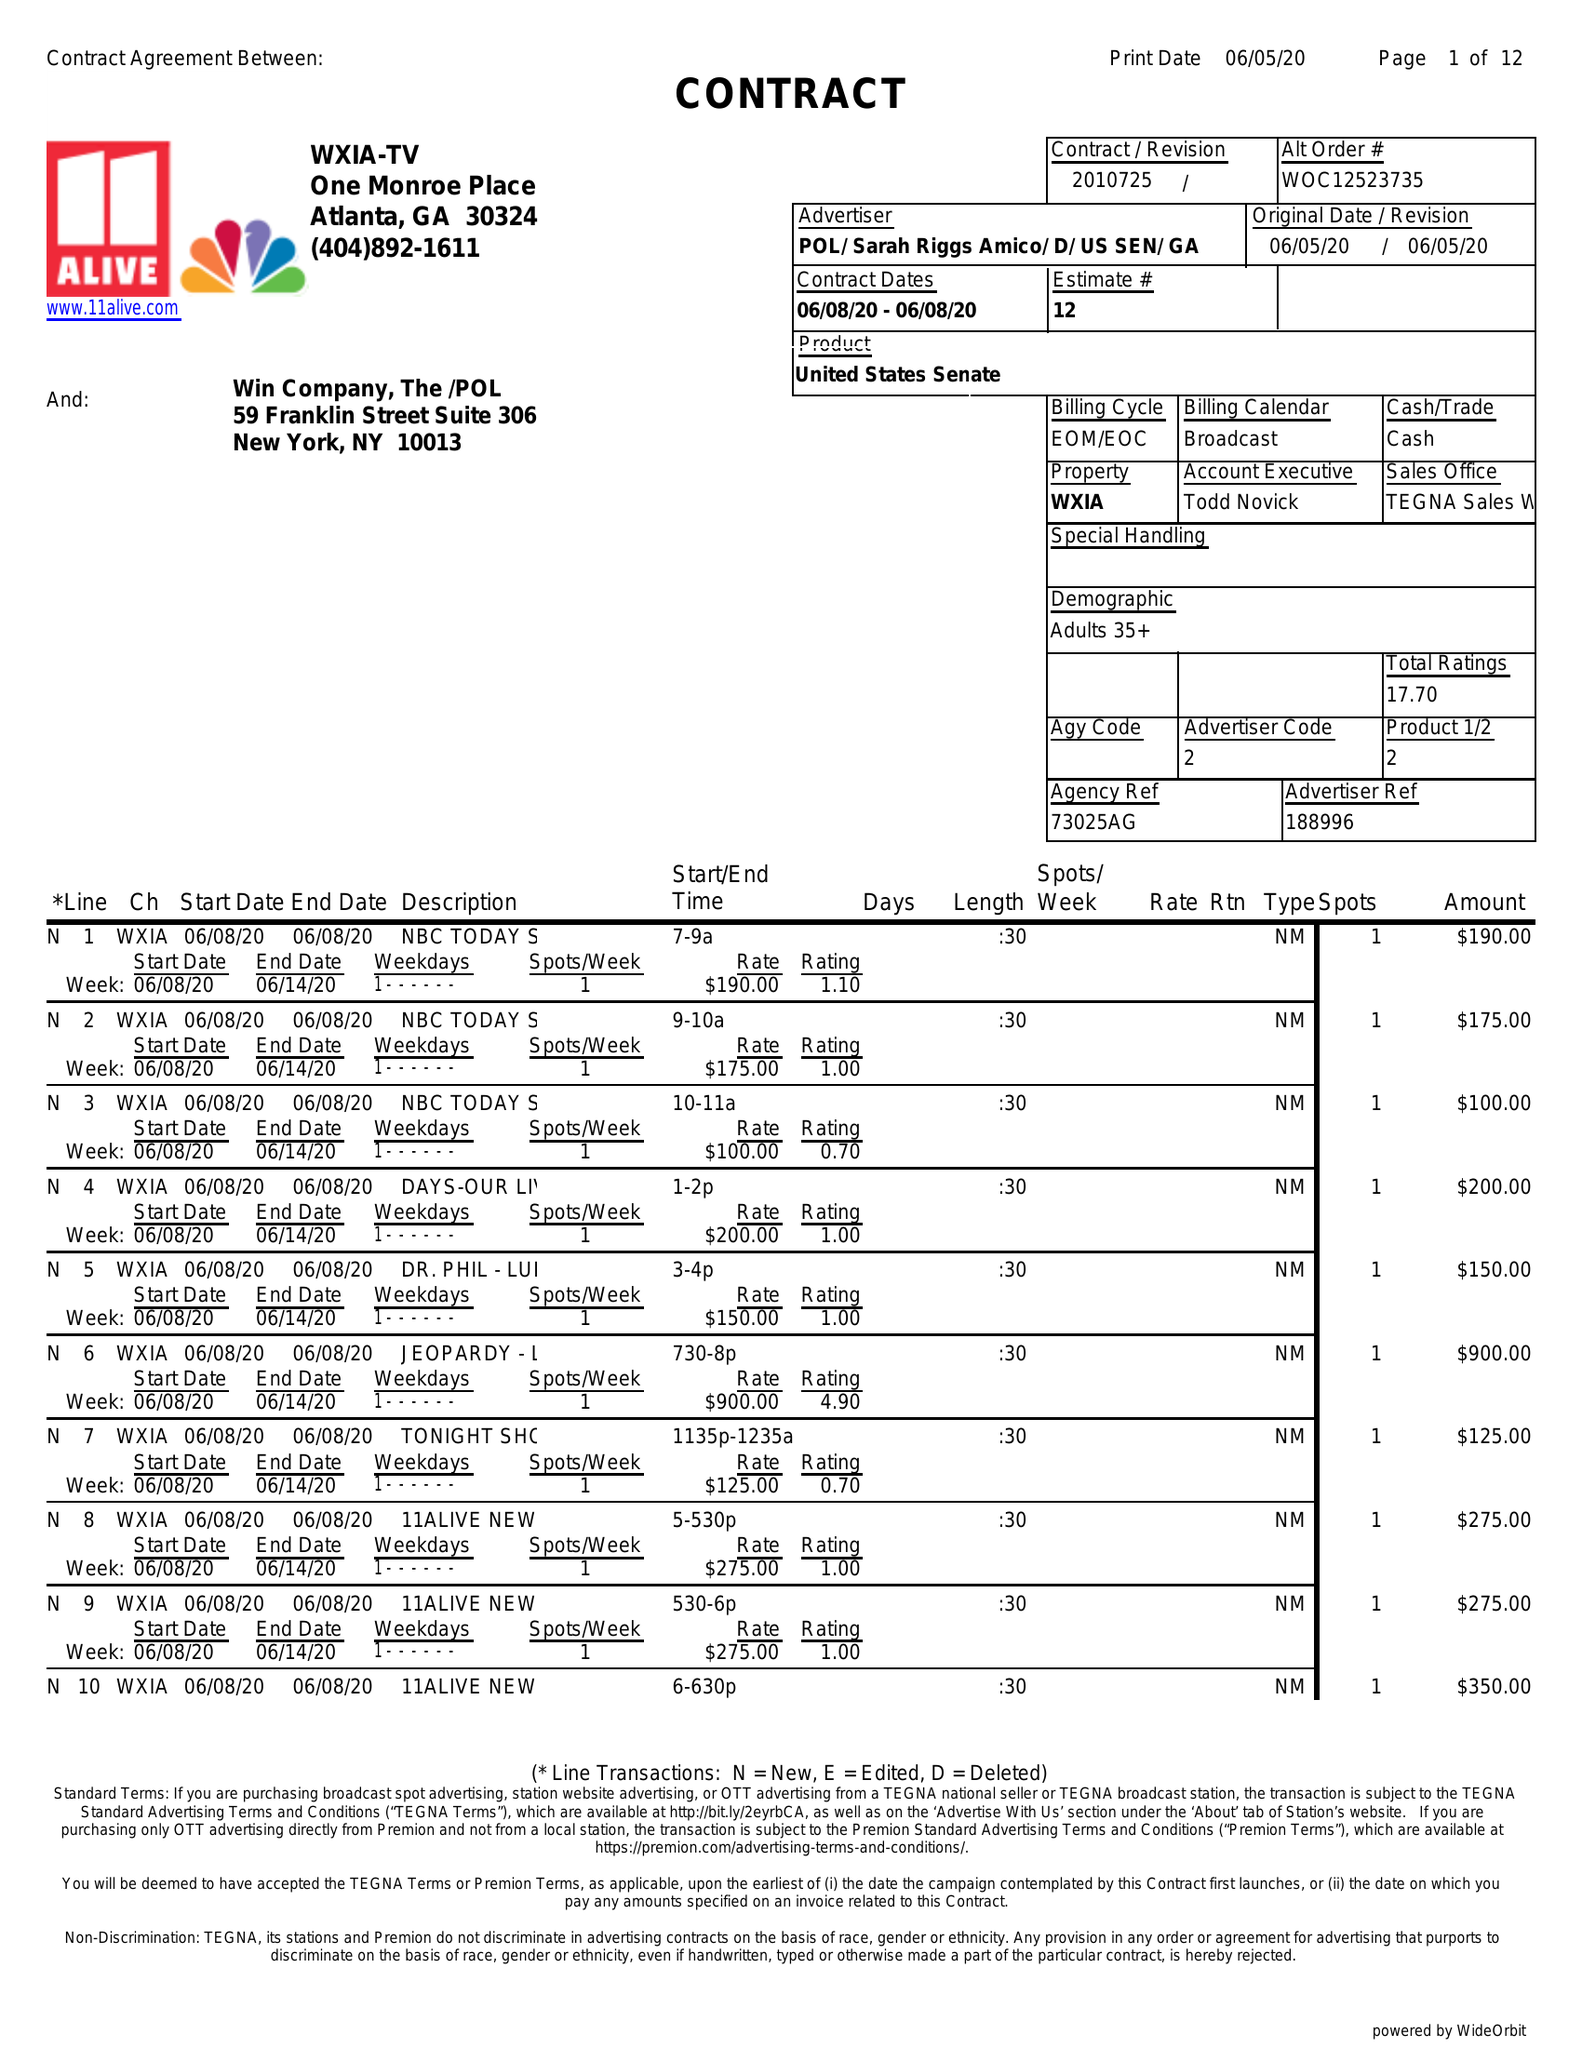What is the value for the gross_amount?
Answer the question using a single word or phrase. 4025.00 